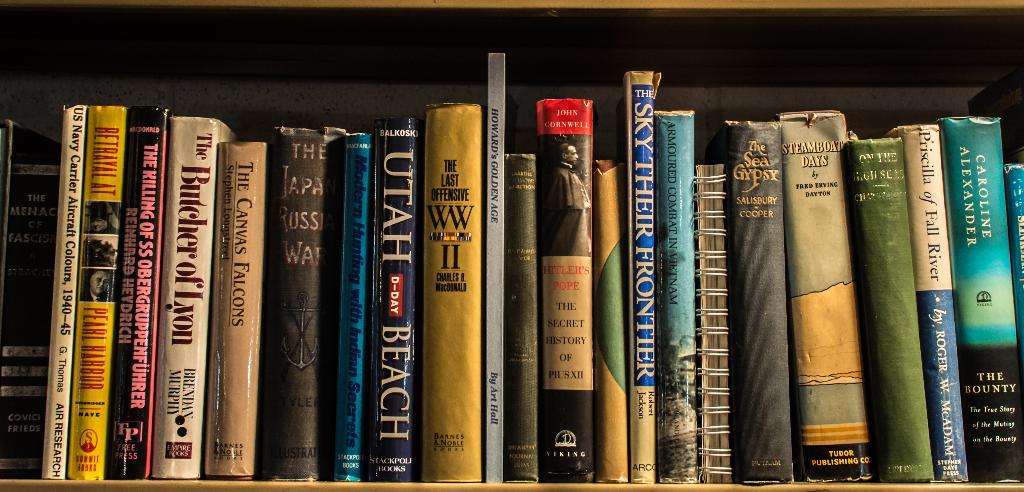What is the title of the black book with white writing?
Offer a terse response. Utah beach. Who wrote the book "steamboat days"?
Your response must be concise. Fred erving dayton. 